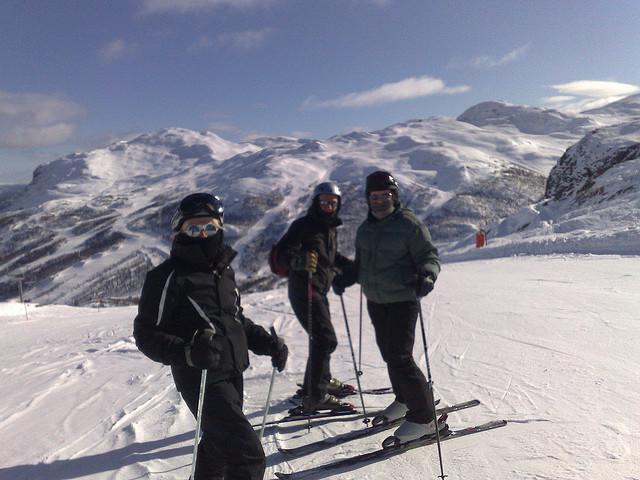What sport are the men doing?
Quick response, please. Skiing. Are the skiers appropriately dressed?
Quick response, please. Yes. How many skiers are there?
Give a very brief answer. 3. IS this at sea level?
Short answer required. No. 